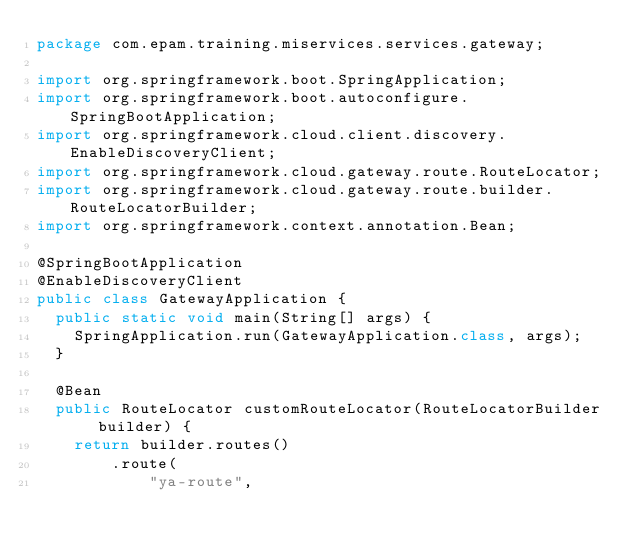<code> <loc_0><loc_0><loc_500><loc_500><_Java_>package com.epam.training.miservices.services.gateway;

import org.springframework.boot.SpringApplication;
import org.springframework.boot.autoconfigure.SpringBootApplication;
import org.springframework.cloud.client.discovery.EnableDiscoveryClient;
import org.springframework.cloud.gateway.route.RouteLocator;
import org.springframework.cloud.gateway.route.builder.RouteLocatorBuilder;
import org.springframework.context.annotation.Bean;

@SpringBootApplication
@EnableDiscoveryClient
public class GatewayApplication {
  public static void main(String[] args) {
    SpringApplication.run(GatewayApplication.class, args);
  }

  @Bean
  public RouteLocator customRouteLocator(RouteLocatorBuilder builder) {
    return builder.routes()
        .route(
            "ya-route",</code> 